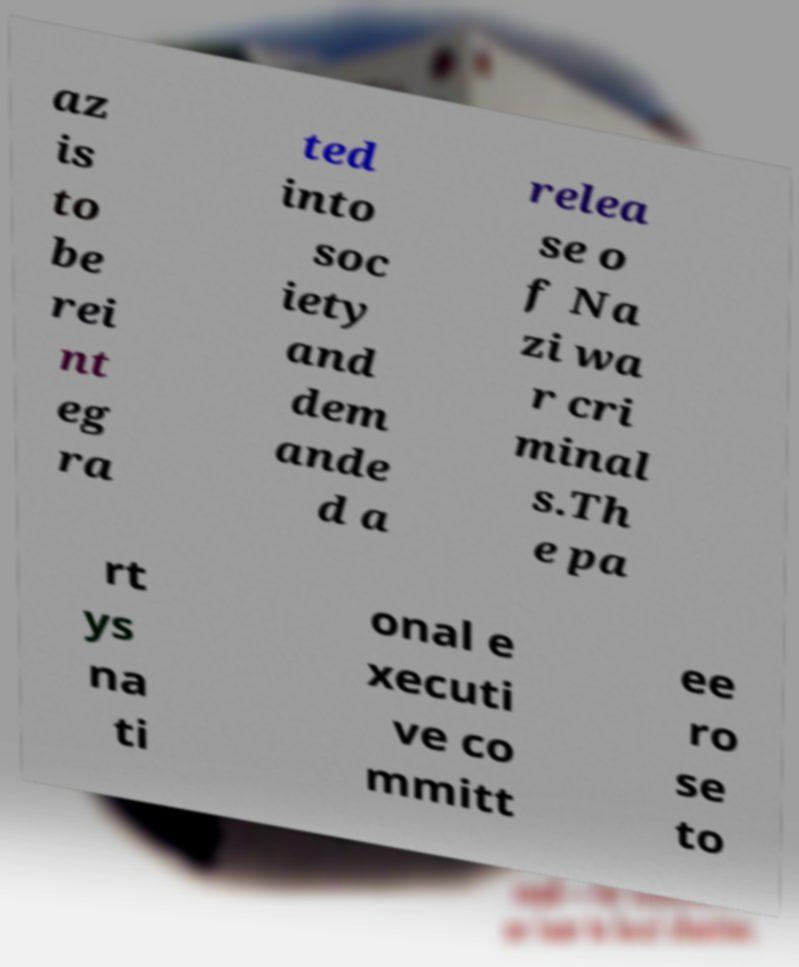What messages or text are displayed in this image? I need them in a readable, typed format. az is to be rei nt eg ra ted into soc iety and dem ande d a relea se o f Na zi wa r cri minal s.Th e pa rt ys na ti onal e xecuti ve co mmitt ee ro se to 